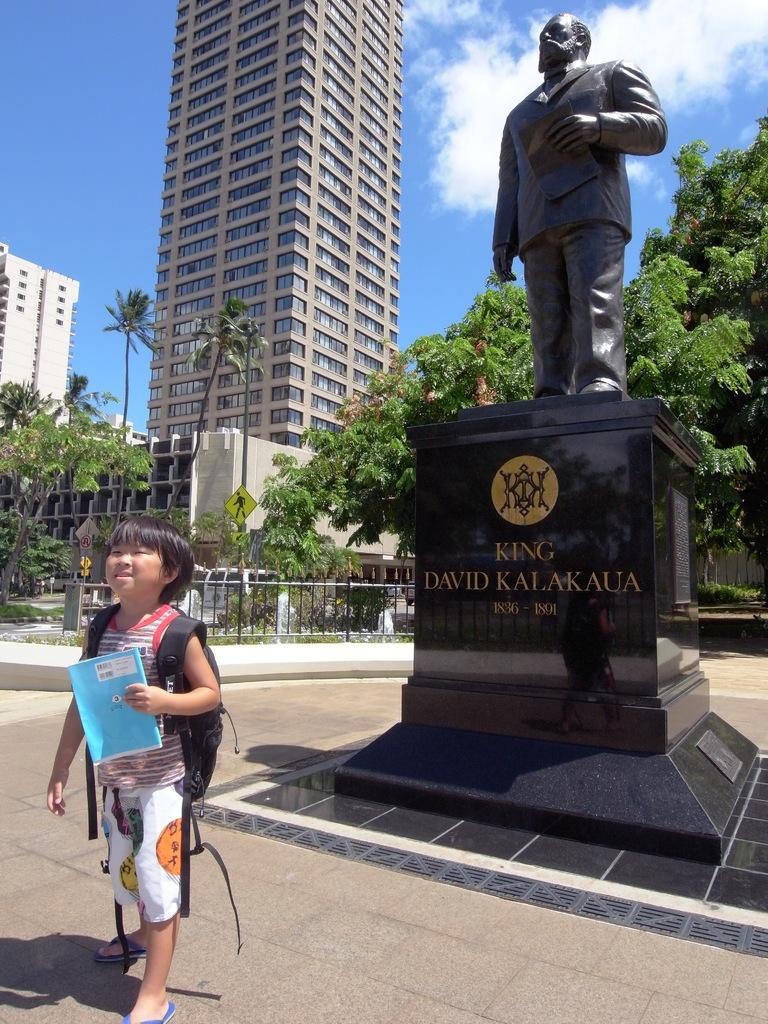How would you summarize this image in a sentence or two? In the image I can see a child is standing and holding a book in the hand. The child is carrying a bag. In the background I can see trees, fence, statue, buildings and the sky. 